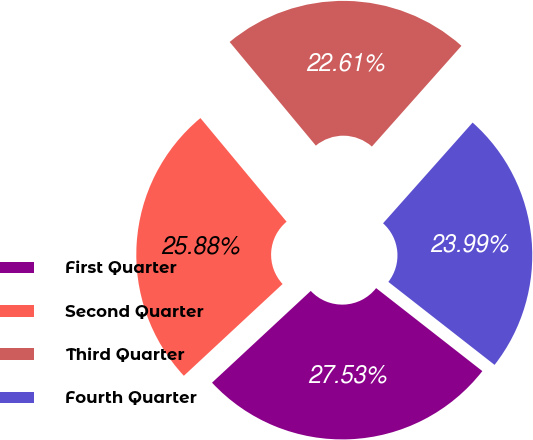Convert chart to OTSL. <chart><loc_0><loc_0><loc_500><loc_500><pie_chart><fcel>First Quarter<fcel>Second Quarter<fcel>Third Quarter<fcel>Fourth Quarter<nl><fcel>27.53%<fcel>25.88%<fcel>22.61%<fcel>23.99%<nl></chart> 